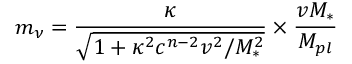Convert formula to latex. <formula><loc_0><loc_0><loc_500><loc_500>m _ { \nu } = \frac { \kappa } { \sqrt { 1 + \kappa ^ { 2 } c ^ { n - 2 } v ^ { 2 } / M _ { * } ^ { 2 } } } \times \frac { v M _ { * } } { M _ { p l } }</formula> 